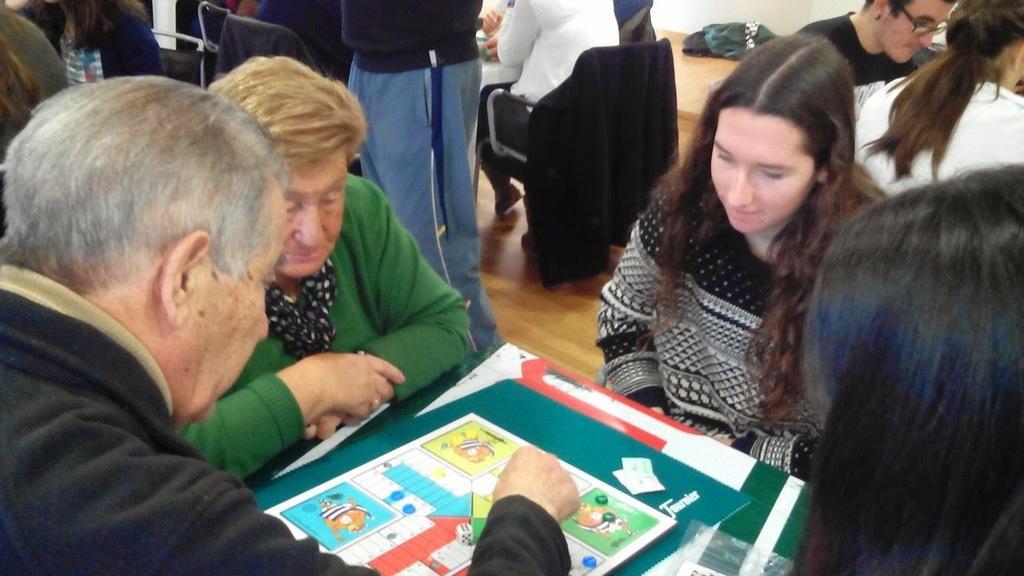Describe this image in one or two sentences. In this image there are group of people sitting in chair and on table they are playing a ludo game ,and in the back ground there are group of persons standing , cloth, table. 